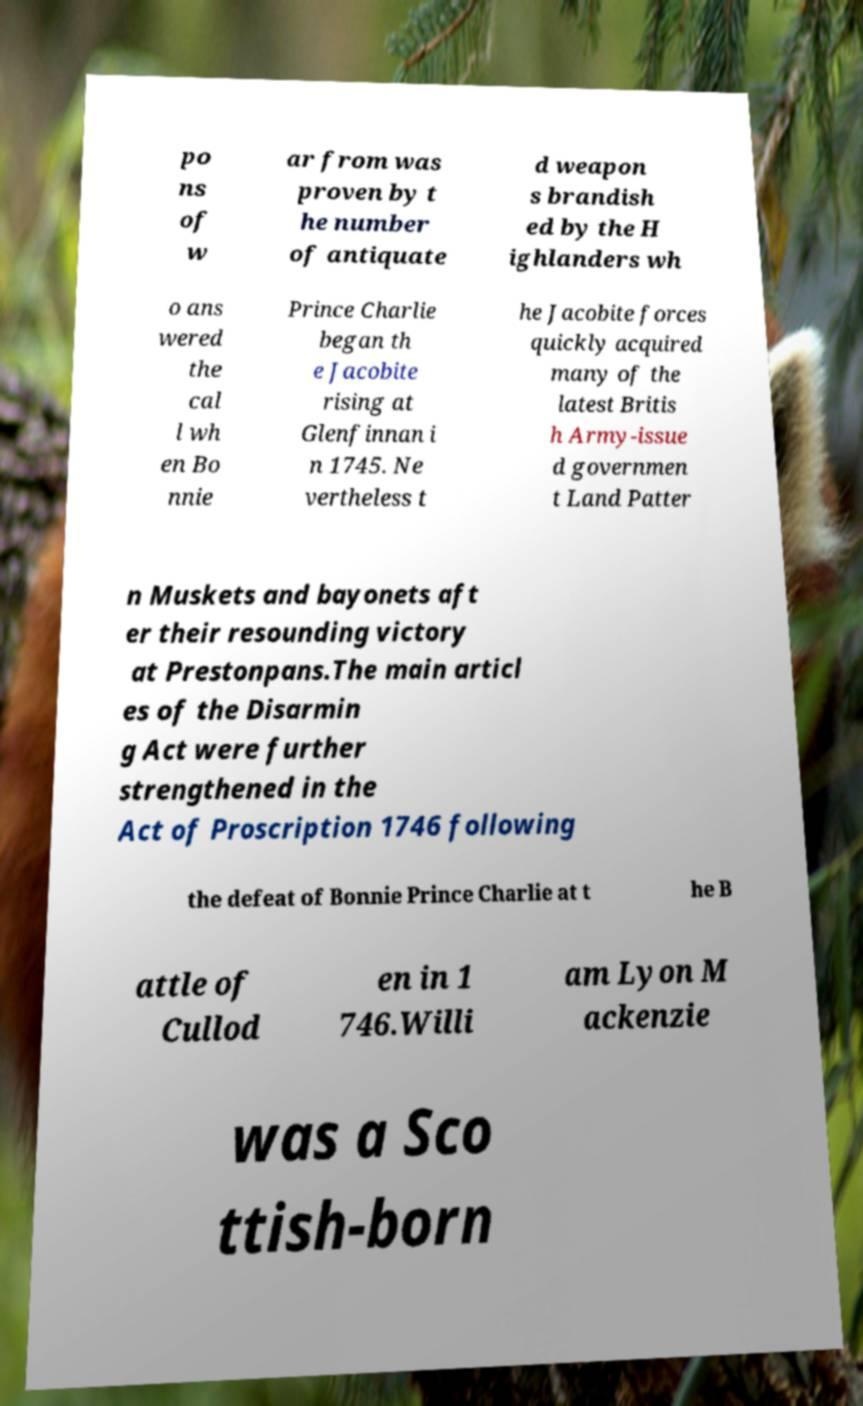Please identify and transcribe the text found in this image. po ns of w ar from was proven by t he number of antiquate d weapon s brandish ed by the H ighlanders wh o ans wered the cal l wh en Bo nnie Prince Charlie began th e Jacobite rising at Glenfinnan i n 1745. Ne vertheless t he Jacobite forces quickly acquired many of the latest Britis h Army-issue d governmen t Land Patter n Muskets and bayonets aft er their resounding victory at Prestonpans.The main articl es of the Disarmin g Act were further strengthened in the Act of Proscription 1746 following the defeat of Bonnie Prince Charlie at t he B attle of Cullod en in 1 746.Willi am Lyon M ackenzie was a Sco ttish-born 